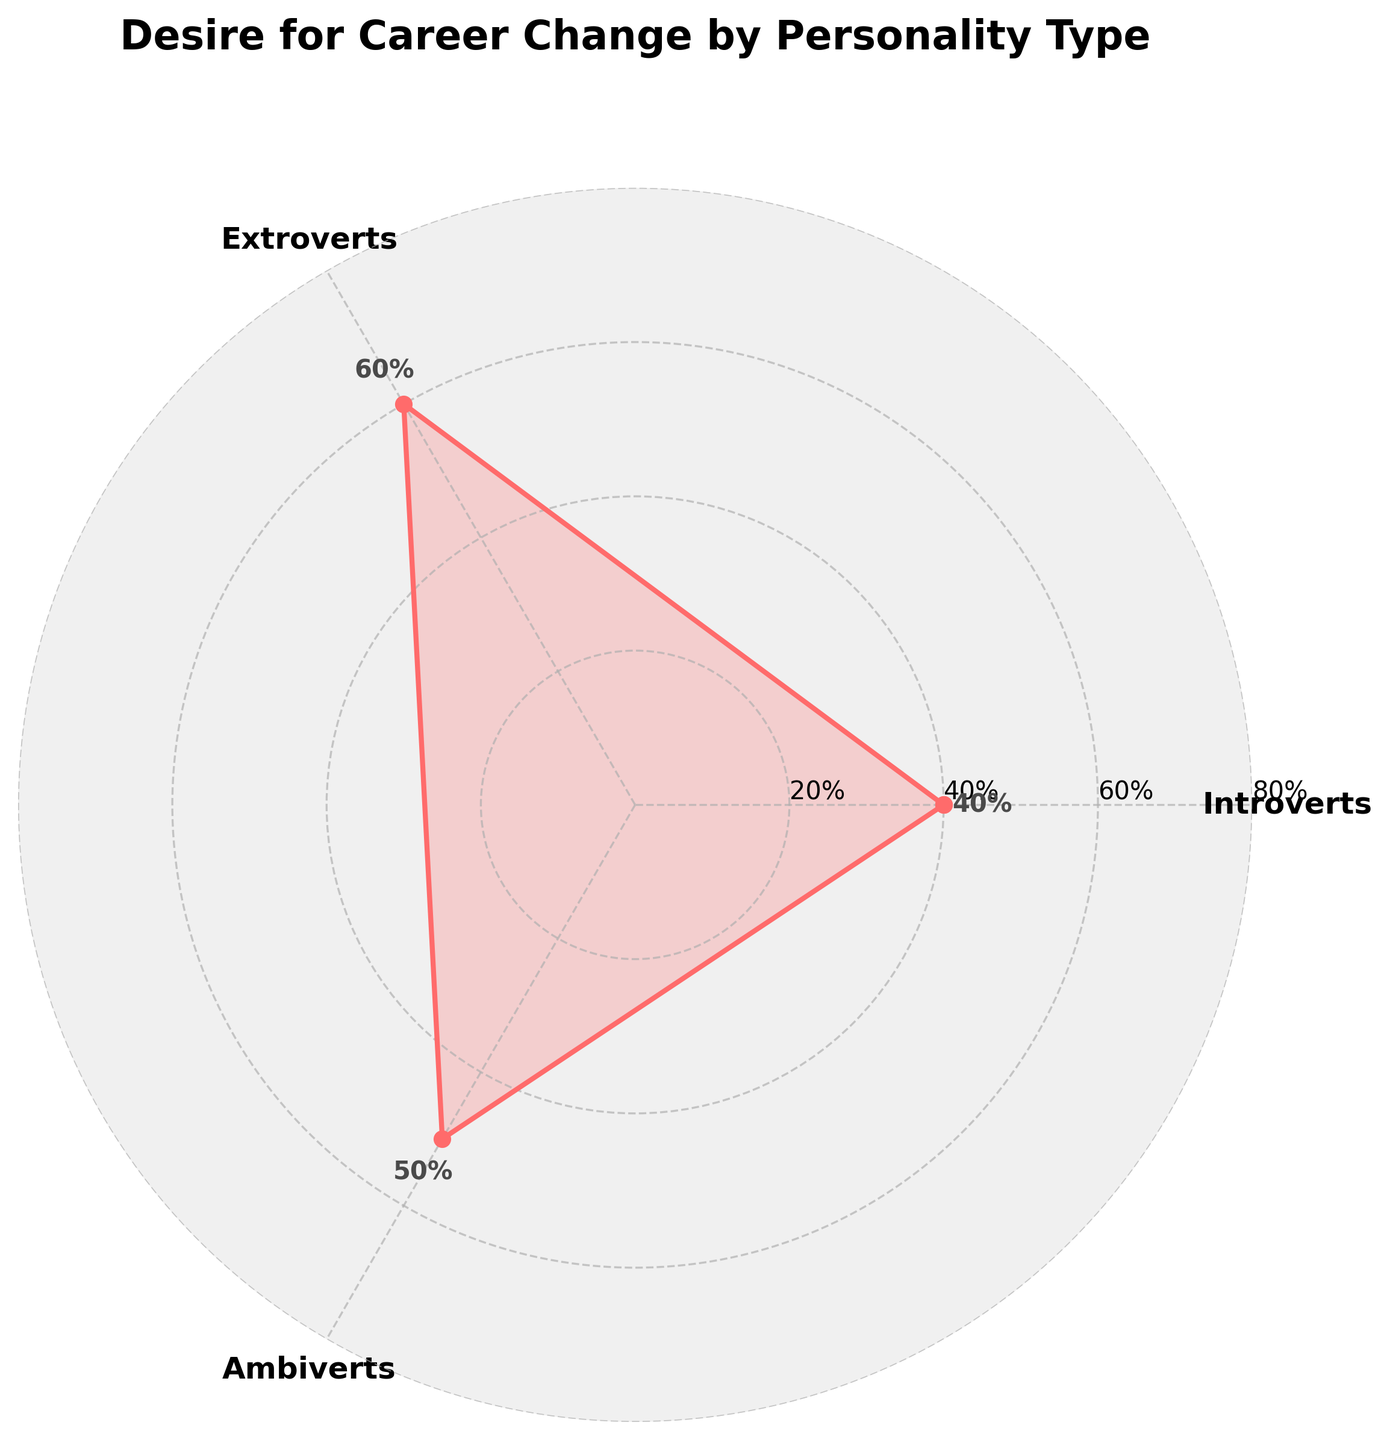What's the title of the figure? The title of the figure is written at the top of the rose chart in large, bold font. It helps to understand the context of the visualized data.
Answer: Desire for Career Change by Personality Type How many personality types are included in the figure? By counting the labels around the plot, you can identify there are three different personality types.
Answer: 3 What percentage of introverts desire a career change? This is directly noted next to the data point for introverts on the chart, often marked with a percentage value.
Answer: 40% Which personality type has the highest desire for a career change? By analyzing the data points, you can see which value peaks the most on the plot.
Answer: Extroverts Which personality type has the lowest desire for a career change? By checking the data points, the lowest value can be identified easily.
Answer: Introverts What is the average desire for a career change across all personality types? To calculate the average, sum up the percentages for all types (40 + 60 + 50), then divide by the number of types (3): (40 + 60 + 50) / 3 = 50
Answer: 50% How much higher is the desire for a career change in extroverts compared to introverts? Subtract the percentage for introverts (40%) from that for extroverts (60%): 60 - 40 = 20
Answer: 20% Compare the desire for a career change between extroverts and ambiverts. The difference between extroverts (60%) and ambiverts (50%) is calculated by subtracting these two values: 60 - 50 = 10
Answer: 10% What is the desirability order of career change among different personality types from highest to lowest? By examining the percentage values: Extroverts (60%), Ambiverts (50%), Introverts (40%)
Answer: Extroverts > Ambiverts > Introverts 